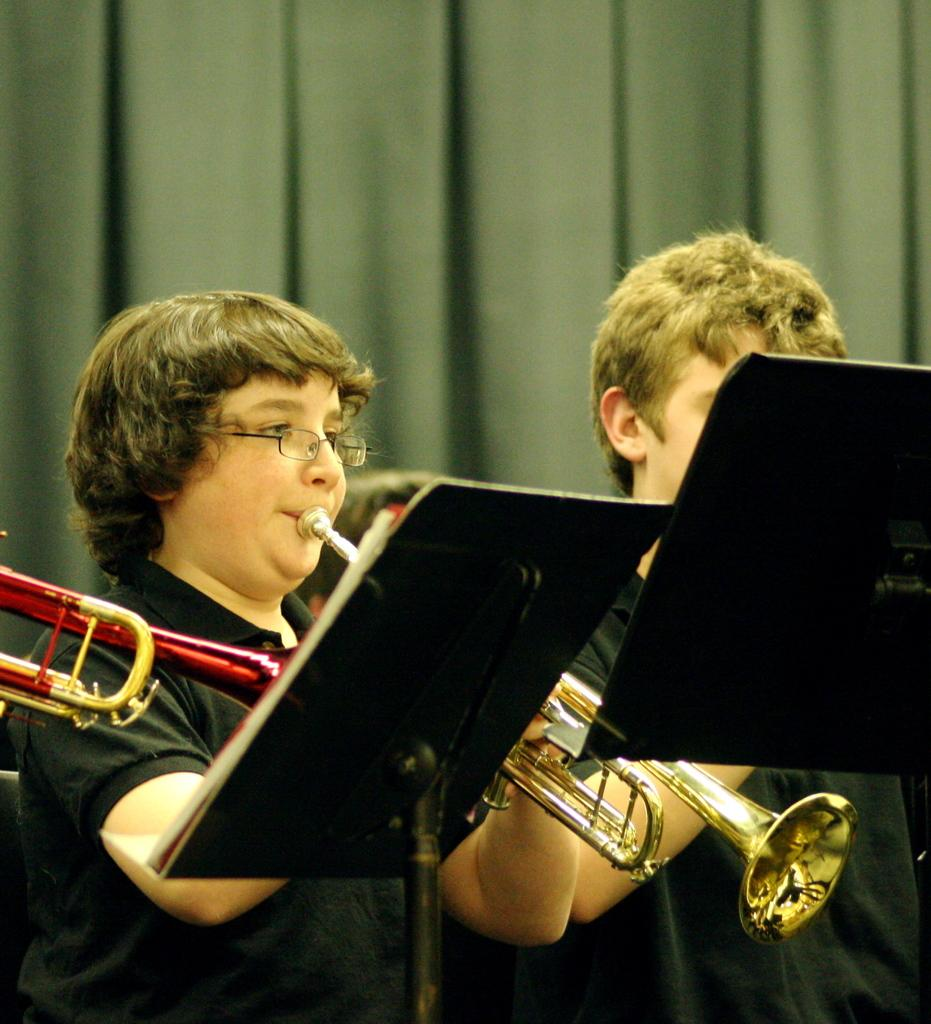What are the people in the image doing? The people in the image are playing trumpets. What objects are placed in front of the trumpet players? There are books placed on stands before the trumpet players. What can be seen in the background of the image? There is a curtain in the background of the image. What type of treatment is being administered to the trumpet players in the image? There is no treatment being administered to the trumpet players in the image; they are simply playing their instruments. 